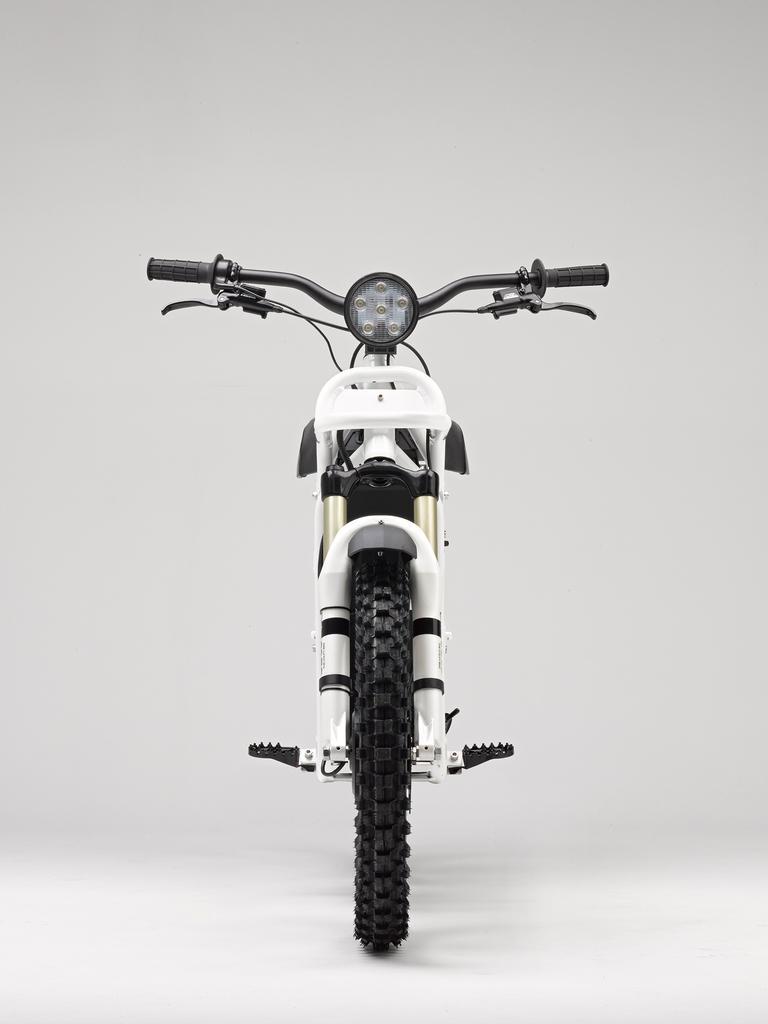Please provide a concise description of this image. In this picture there is a bicycle with is facing forward and the background is white. 